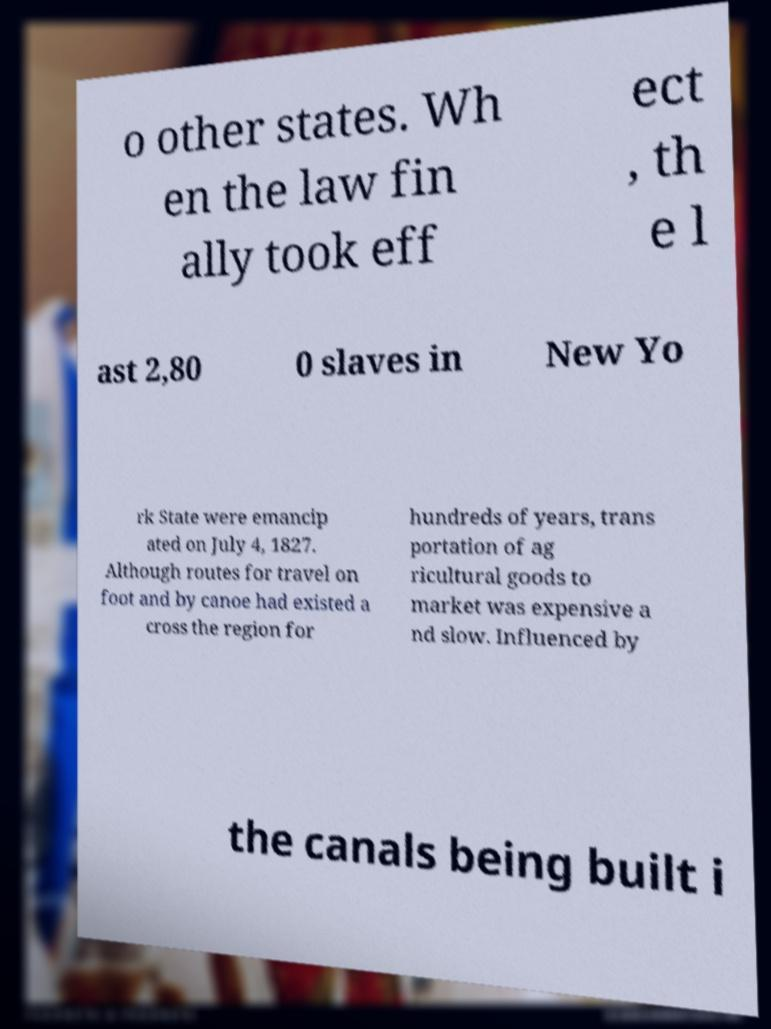What messages or text are displayed in this image? I need them in a readable, typed format. o other states. Wh en the law fin ally took eff ect , th e l ast 2,80 0 slaves in New Yo rk State were emancip ated on July 4, 1827. Although routes for travel on foot and by canoe had existed a cross the region for hundreds of years, trans portation of ag ricultural goods to market was expensive a nd slow. Influenced by the canals being built i 